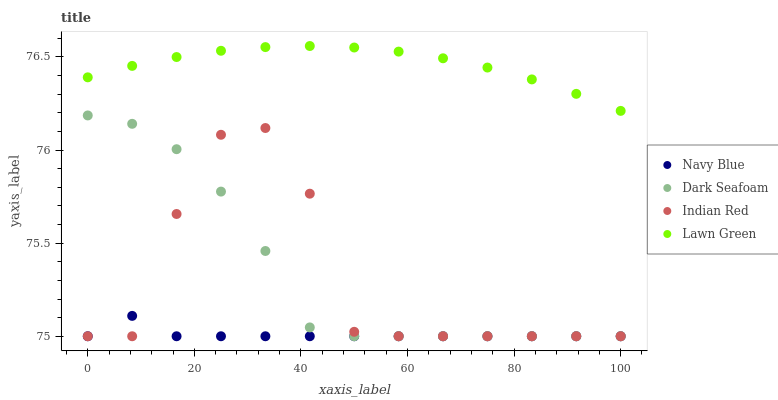Does Navy Blue have the minimum area under the curve?
Answer yes or no. Yes. Does Lawn Green have the maximum area under the curve?
Answer yes or no. Yes. Does Dark Seafoam have the minimum area under the curve?
Answer yes or no. No. Does Dark Seafoam have the maximum area under the curve?
Answer yes or no. No. Is Lawn Green the smoothest?
Answer yes or no. Yes. Is Indian Red the roughest?
Answer yes or no. Yes. Is Dark Seafoam the smoothest?
Answer yes or no. No. Is Dark Seafoam the roughest?
Answer yes or no. No. Does Navy Blue have the lowest value?
Answer yes or no. Yes. Does Lawn Green have the lowest value?
Answer yes or no. No. Does Lawn Green have the highest value?
Answer yes or no. Yes. Does Dark Seafoam have the highest value?
Answer yes or no. No. Is Dark Seafoam less than Lawn Green?
Answer yes or no. Yes. Is Lawn Green greater than Indian Red?
Answer yes or no. Yes. Does Indian Red intersect Dark Seafoam?
Answer yes or no. Yes. Is Indian Red less than Dark Seafoam?
Answer yes or no. No. Is Indian Red greater than Dark Seafoam?
Answer yes or no. No. Does Dark Seafoam intersect Lawn Green?
Answer yes or no. No. 